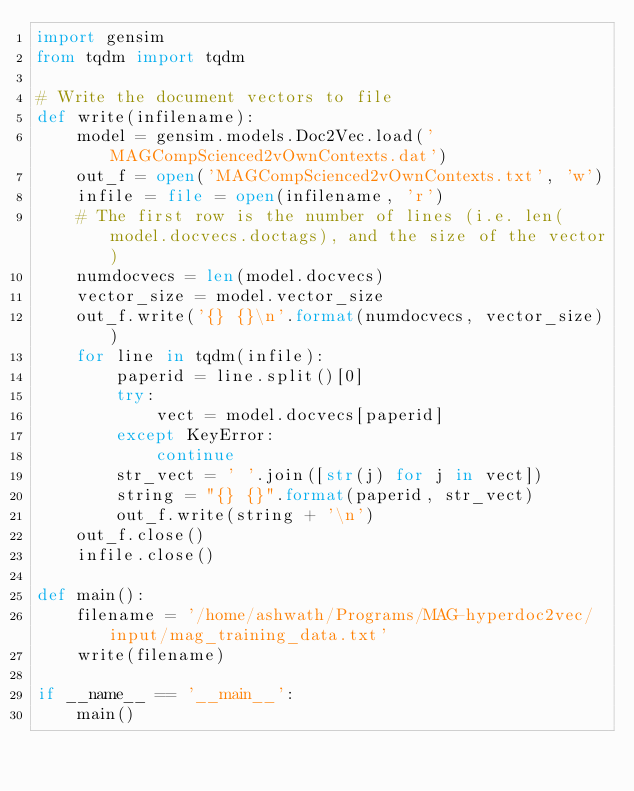<code> <loc_0><loc_0><loc_500><loc_500><_Python_>import gensim
from tqdm import tqdm

# Write the document vectors to file
def write(infilename):
    model = gensim.models.Doc2Vec.load('MAGCompScienced2vOwnContexts.dat')
    out_f = open('MAGCompScienced2vOwnContexts.txt', 'w')
    infile = file = open(infilename, 'r')
    # The first row is the number of lines (i.e. len(model.docvecs.doctags), and the size of the vector)
    numdocvecs = len(model.docvecs)
    vector_size = model.vector_size
    out_f.write('{} {}\n'.format(numdocvecs, vector_size))
    for line in tqdm(infile):
        paperid = line.split()[0]
        try:
            vect = model.docvecs[paperid]
        except KeyError:
            continue
        str_vect = ' '.join([str(j) for j in vect])
        string = "{} {}".format(paperid, str_vect) 
        out_f.write(string + '\n')
    out_f.close()
    infile.close()

def main():
    filename = '/home/ashwath/Programs/MAG-hyperdoc2vec/input/mag_training_data.txt'
    write(filename)

if __name__ == '__main__':
    main()</code> 